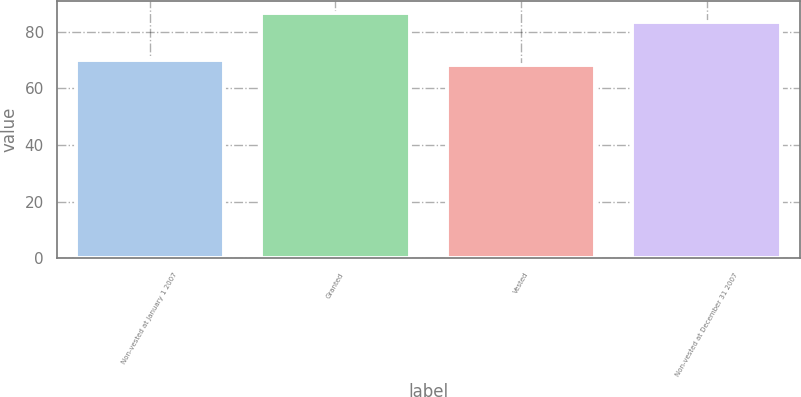Convert chart. <chart><loc_0><loc_0><loc_500><loc_500><bar_chart><fcel>Non-vested at January 1 2007<fcel>Granted<fcel>Vested<fcel>Non-vested at December 31 2007<nl><fcel>69.97<fcel>86.57<fcel>68.12<fcel>83.37<nl></chart> 